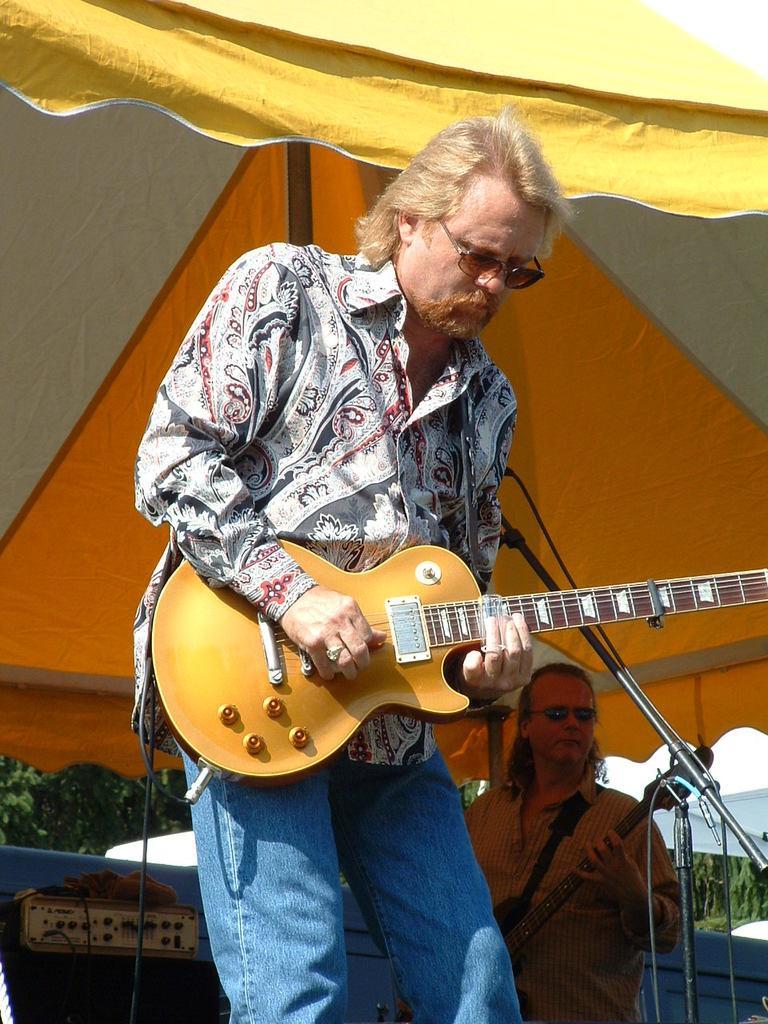Describe this image in one or two sentences. Man in the middle of the picture wearing colorful shirt is holding guitar in his hands and playing it. He is even wearing goggles. Behind him, man in yellow shirt is also holding guitar in his hands. On top of picture, we see yellow and white tent. On background, we see trees. 